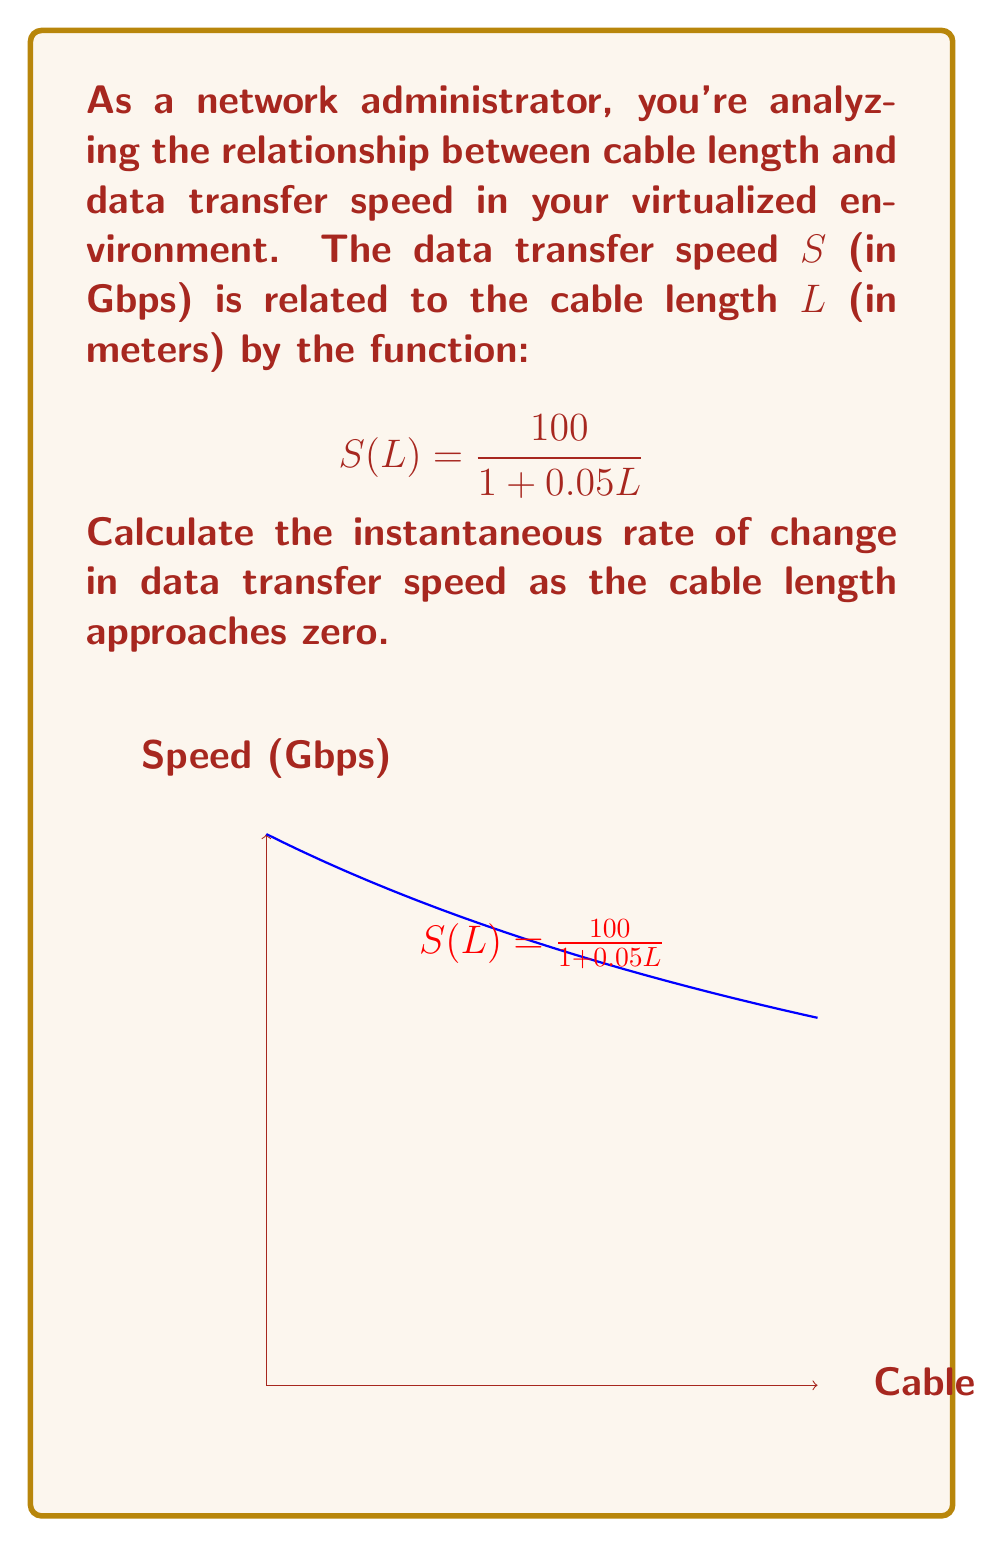Give your solution to this math problem. To find the instantaneous rate of change as cable length approaches zero, we need to calculate the limit of the derivative of $S(L)$ as $L$ approaches 0.

Step 1: Find the derivative of $S(L)$ using the quotient rule.
$$S'(L) = \frac{d}{dL}\left(\frac{100}{1 + 0.05L}\right) = \frac{-100 \cdot 0.05}{(1 + 0.05L)^2} = \frac{-5}{(1 + 0.05L)^2}$$

Step 2: Calculate the limit of $S'(L)$ as $L$ approaches 0.
$$\lim_{L \to 0} S'(L) = \lim_{L \to 0} \frac{-5}{(1 + 0.05L)^2}$$

Step 3: Evaluate the limit by substituting $L = 0$.
$$\lim_{L \to 0} \frac{-5}{(1 + 0.05L)^2} = \frac{-5}{(1 + 0.05 \cdot 0)^2} = \frac{-5}{1^2} = -5$$

The negative sign indicates that as cable length increases, the data transfer speed decreases, which is consistent with real-world behavior.
Answer: $-5$ Gbps/m 